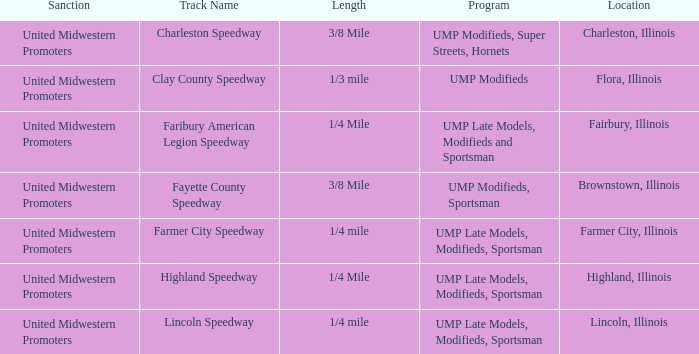Who sanctioned the event in lincoln, illinois? United Midwestern Promoters. 